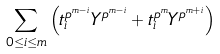Convert formula to latex. <formula><loc_0><loc_0><loc_500><loc_500>\sum _ { 0 \leq i \leq m } \left ( t _ { i } ^ { p ^ { m - i } } Y ^ { p ^ { m - i } } + t _ { i } ^ { p ^ { m } } Y ^ { p ^ { m + i } } \right )</formula> 